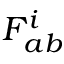<formula> <loc_0><loc_0><loc_500><loc_500>F _ { a b } ^ { i }</formula> 